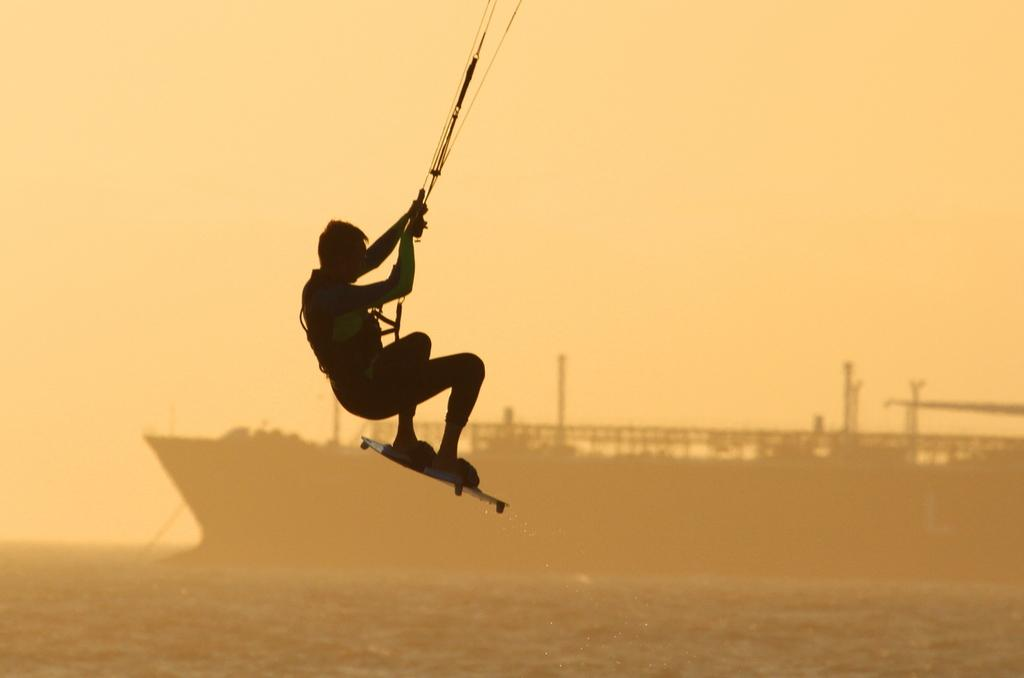What is the main subject of the image? There is a person in the image. What is the person doing in the image? The person is hanging in the air. What is the person wearing in the image? The person is wearing a surfing board. What can be seen in the background of the image? There is a ship in the background of the image. What is the ship located on in the image? The ship is on a water body. What type of bubble can be seen surrounding the person in the image? There is no bubble surrounding the person in the image. What is the person arguing about with the ship in the image? There is no argument present in the image; the person is surfing and the ship is on a water body in the background. 